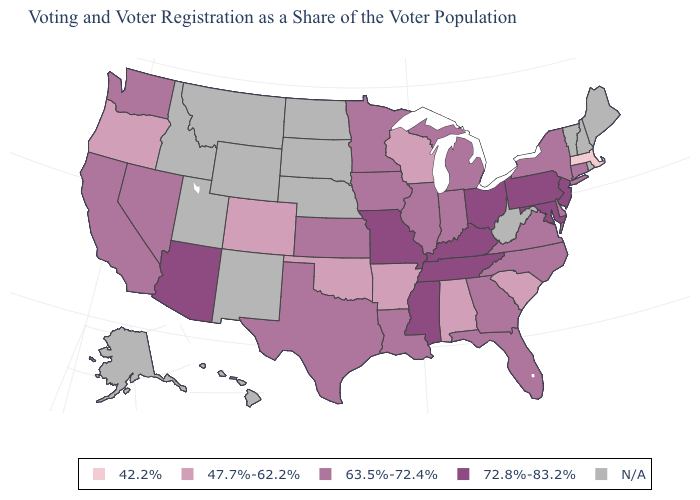What is the highest value in the USA?
Answer briefly. 72.8%-83.2%. What is the value of Kansas?
Concise answer only. 63.5%-72.4%. Which states hav the highest value in the West?
Short answer required. Arizona. Does Delaware have the highest value in the USA?
Keep it brief. No. Name the states that have a value in the range 47.7%-62.2%?
Concise answer only. Alabama, Arkansas, Colorado, Oklahoma, Oregon, South Carolina, Wisconsin. What is the highest value in states that border North Dakota?
Answer briefly. 63.5%-72.4%. What is the lowest value in the USA?
Quick response, please. 42.2%. What is the value of Wisconsin?
Give a very brief answer. 47.7%-62.2%. Name the states that have a value in the range 72.8%-83.2%?
Quick response, please. Arizona, Kentucky, Maryland, Mississippi, Missouri, New Jersey, Ohio, Pennsylvania, Tennessee. Name the states that have a value in the range N/A?
Keep it brief. Alaska, Hawaii, Idaho, Maine, Montana, Nebraska, New Hampshire, New Mexico, North Dakota, Rhode Island, South Dakota, Utah, Vermont, West Virginia, Wyoming. Name the states that have a value in the range 42.2%?
Give a very brief answer. Massachusetts. What is the value of Indiana?
Give a very brief answer. 63.5%-72.4%. Among the states that border Massachusetts , which have the lowest value?
Give a very brief answer. Connecticut, New York. Among the states that border Indiana , which have the lowest value?
Be succinct. Illinois, Michigan. 